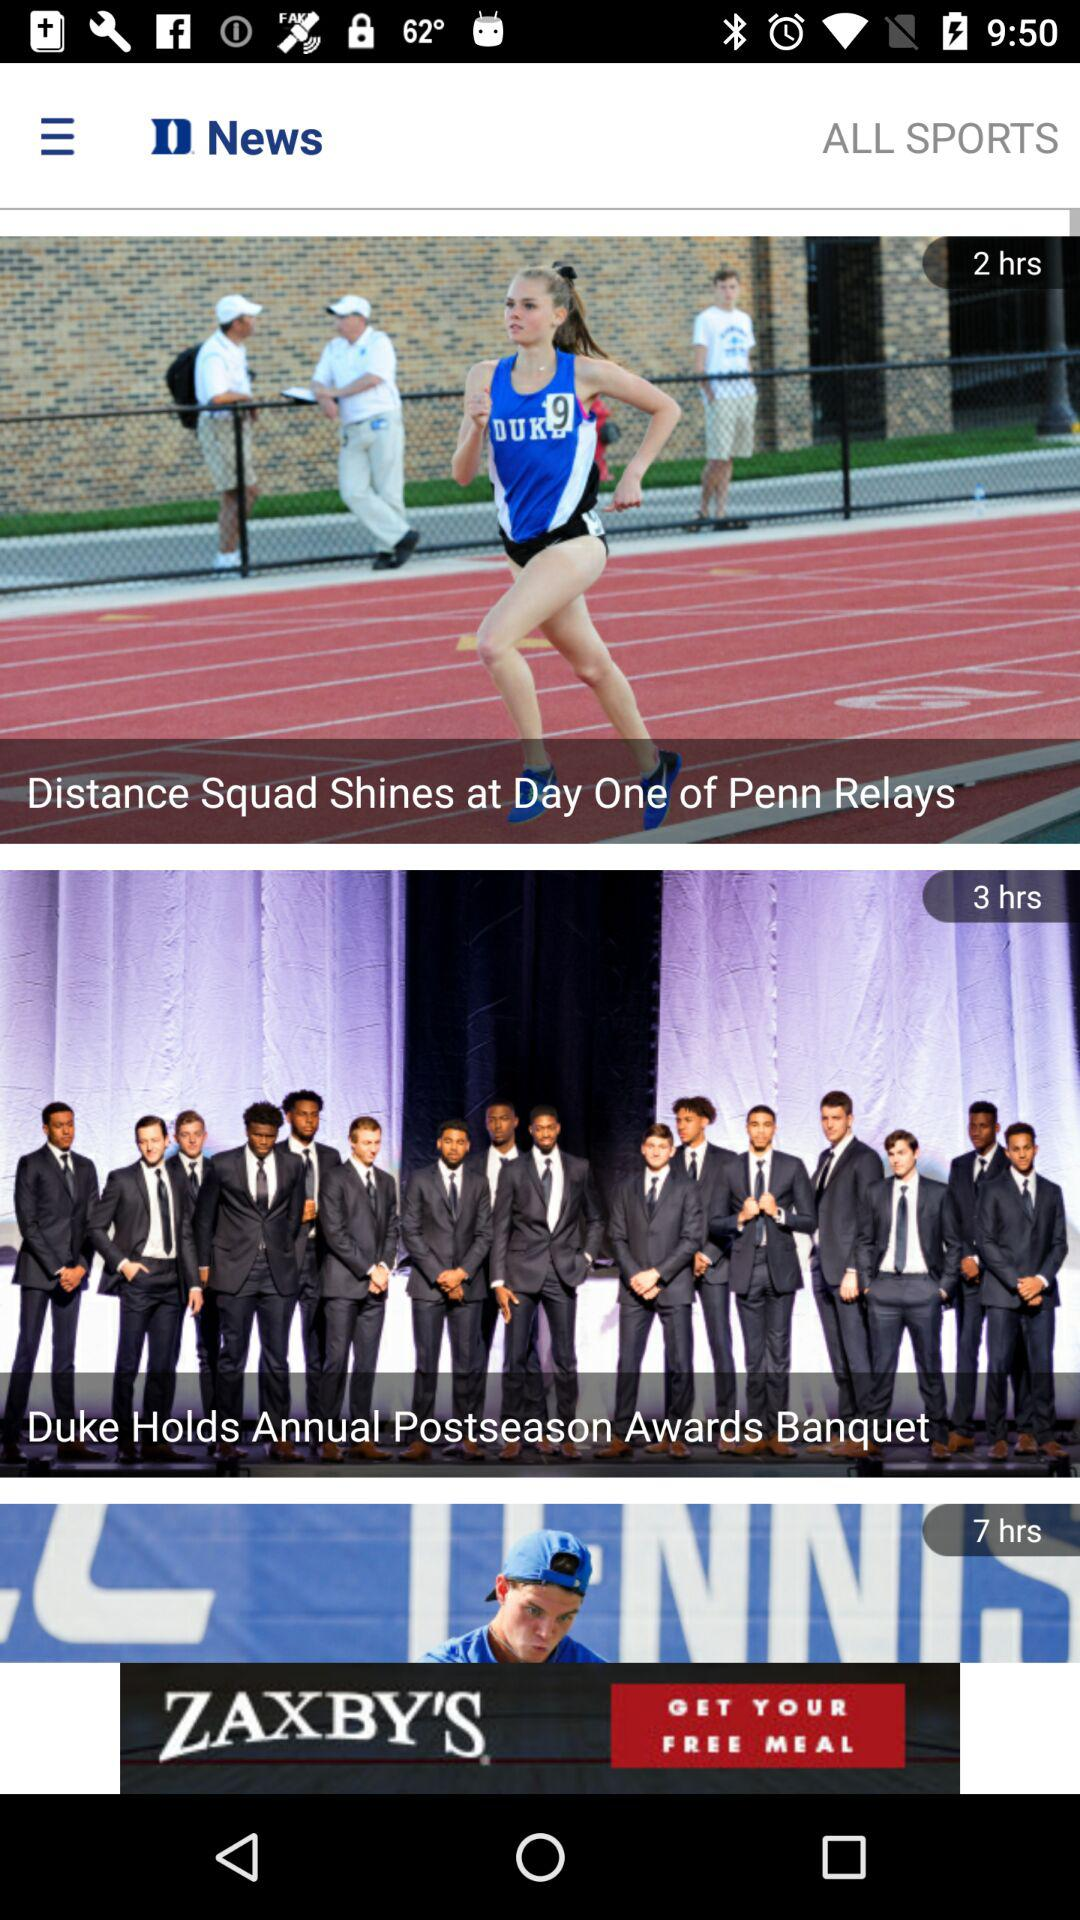How many news articles are displayed on the screen?
Answer the question using a single word or phrase. 3 